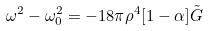<formula> <loc_0><loc_0><loc_500><loc_500>\omega ^ { 2 } - \omega _ { 0 } ^ { 2 } = - 1 8 \pi \rho ^ { 4 } [ 1 - \alpha ] \tilde { G }</formula> 